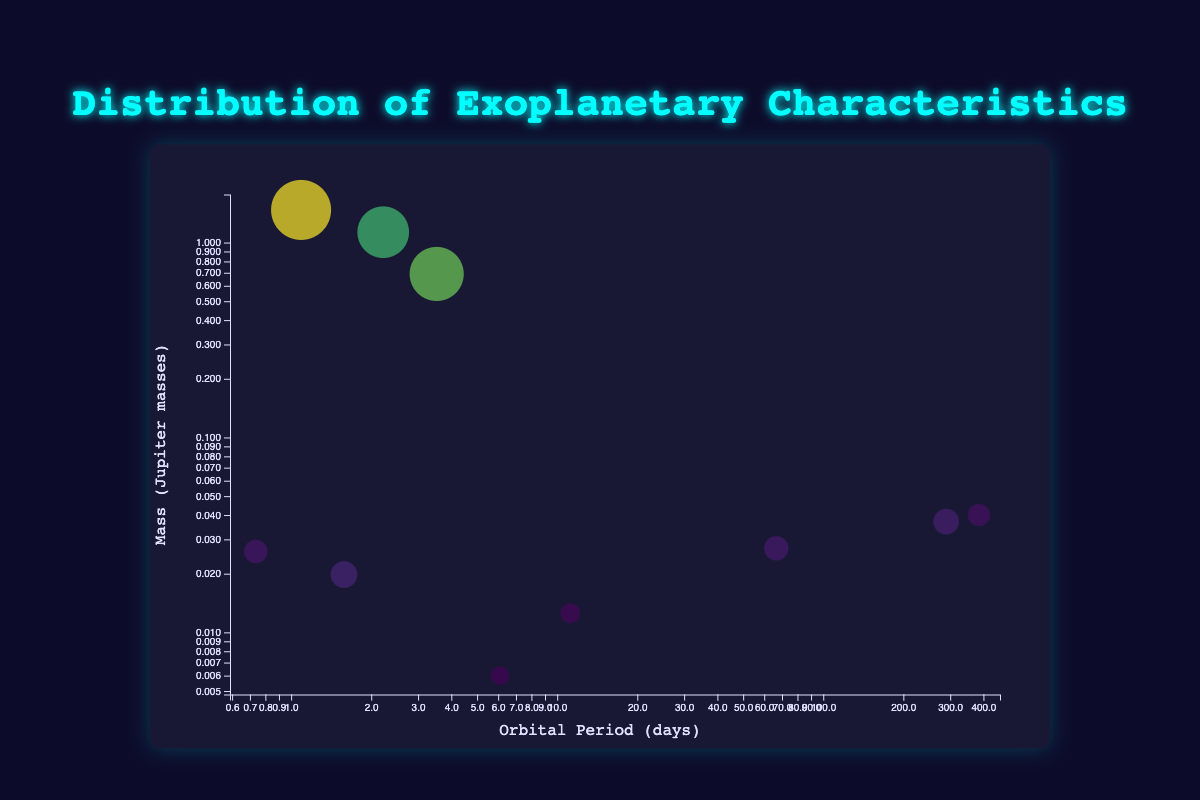What is the title of the figure? The title is displayed at the top center of the figure in a large font size and reads "Distribution of Exoplanetary Characteristics."
Answer: Distribution of Exoplanetary Characteristics What do the colors of the bubbles represent? The colors of the bubbles are mapped using a color scale that changes gradually based on the radius of the exoplanets, which is measured in Earth radii.
Answer: The radius of the exoplanets Which exoplanet has the largest radius? By observing the sizes of the bubbles, the largest radius is represented by the largest bubble. In this case, "WASP-12b" has the largest bubble, indicating it has the largest radius.
Answer: WASP-12b How many exoplanets have an orbital period of fewer than 10 days? By inspecting the graph, we look for bubbles positioned on the left side of the x-axis (orbital period) less than 10. There are four bubbles in this range representing "TRAPPIST-1e," "55 Cancri e," "WASP-12b," and "HD 189733 b."
Answer: Four exoplanets Compare the bubble sizes of "Kepler-22b" and "Kepler-452b." Which one is larger? We compare the size of the bubbles representing "Kepler-22b" and "Kepler-452b" on the chart. "Kepler-22b" has a bubble with a larger radius than "Kepler-452b."
Answer: Kepler-22b Which exoplanet has the shortest orbital period, and what is its mass in Jupiter masses? The shortest orbital period is represented by the bubble closest to the origin on the x-axis. "55 Cancri e" has the shortest orbital period at 0.7365 days, and its mass is 0.026 Jupiter masses.
Answer: 55 Cancri e, 0.026 Jupiter masses Is there any visible correlation between the mass of an exoplanet and its orbital period? Observing the distribution of bubbles, there is no clear linear or logarithmic pattern suggesting any strong correlation between the mass (y-axis) and orbital period (x-axis) of the exoplanets.
Answer: No visible correlation What does the y-axis represent, and how is it scaled? The y-axis represents the mass of the exoplanets in Jupiter masses and is scaled logarithmically, indicated by the non-linear spacing of the tick marks.
Answer: Mass in Jupiter masses, logarithmic scale What is the orbital period of the exoplanet with the second-largest mass? The exoplanet with the second-largest mass has a bubble positioned second highest on the y-axis. This is "HD 189733 b" with an orbital period of 2.219 days.
Answer: 2.219 days Among the exoplanets with an orbital period greater than 50 days, which has the smallest radius? For exoplanets with an orbital period greater than 50 days (bubbles on the right half of the x-axis), we compare their bubble sizes. "Kepler-452b" has a smaller bubble size (1.63 Earth radii) compared to "Kepler-22b" (2.4 Earth radii) and "Gliese 581d" (2.1 Earth radii).
Answer: Kepler-452b 